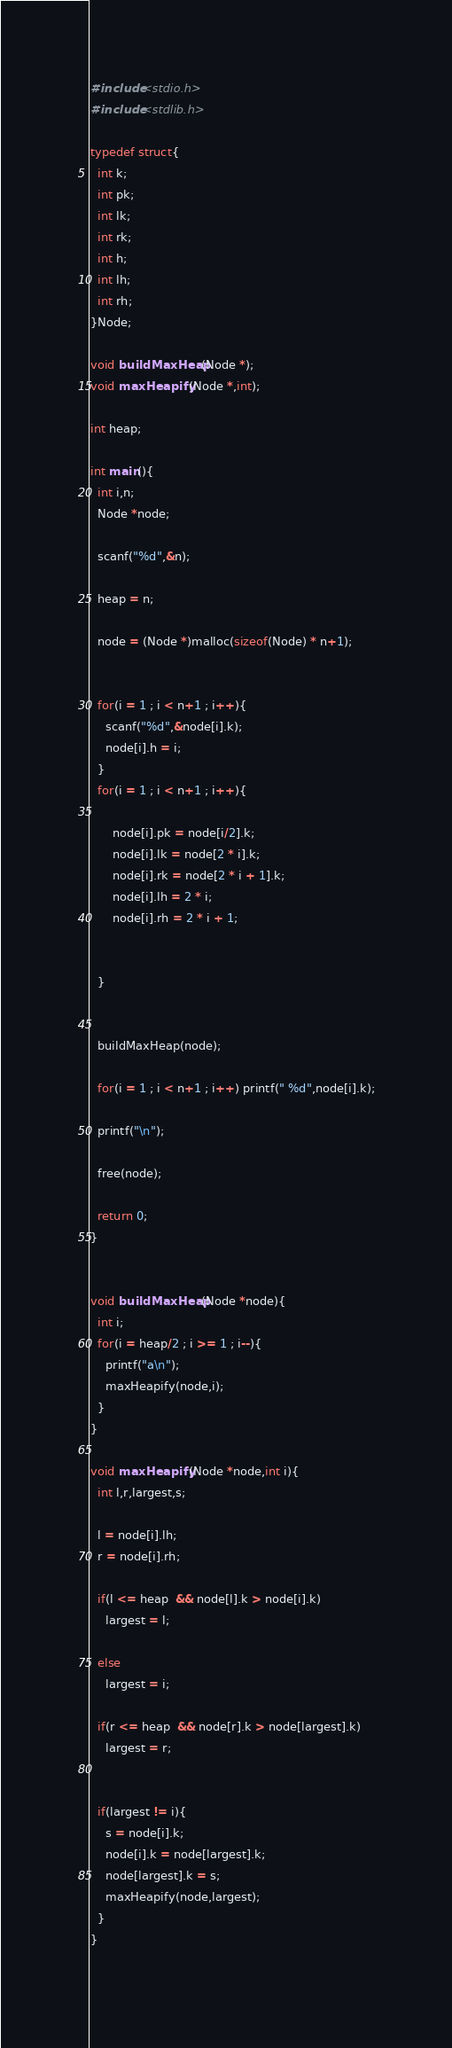Convert code to text. <code><loc_0><loc_0><loc_500><loc_500><_C_>#include<stdio.h>
#include<stdlib.h>

typedef struct{
  int k;
  int pk;
  int lk;
  int rk;
  int h;
  int lh;
  int rh;
}Node;

void buildMaxHeap(Node *);
void maxHeapify(Node *,int);

int heap;

int main(){
  int i,n;
  Node *node;

  scanf("%d",&n);

  heap = n;
  
  node = (Node *)malloc(sizeof(Node) * n+1);

  
  for(i = 1 ; i < n+1 ; i++){
    scanf("%d",&node[i].k);
    node[i].h = i;
  }
  for(i = 1 ; i < n+1 ; i++){
      
      node[i].pk = node[i/2].k;
      node[i].lk = node[2 * i].k;
      node[i].rk = node[2 * i + 1].k;
      node[i].lh = 2 * i;
      node[i].rh = 2 * i + 1;
    
      
  }


  buildMaxHeap(node);
  
  for(i = 1 ; i < n+1 ; i++) printf(" %d",node[i].k);

  printf("\n");

  free(node);

  return 0;
}


void buildMaxHeap(Node *node){
  int i;
  for(i = heap/2 ; i >= 1 ; i--){
    printf("a\n");
    maxHeapify(node,i);
  }
}

void maxHeapify(Node *node,int i){
  int l,r,largest,s;

  l = node[i].lh;
  r = node[i].rh;

  if(l <= heap  && node[l].k > node[i].k)
    largest = l;

  else
    largest = i;

  if(r <= heap  && node[r].k > node[largest].k)
    largest = r;


  if(largest != i){
    s = node[i].k;
    node[i].k = node[largest].k;
    node[largest].k = s;
    maxHeapify(node,largest);
  }
}
    </code> 